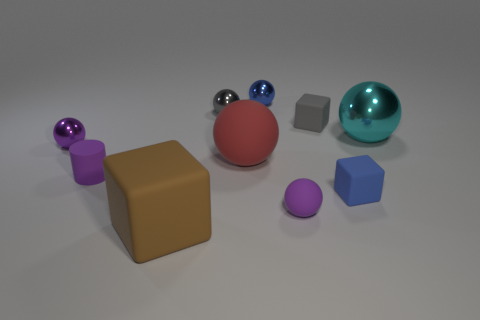What objects in the image are glossy? The objects that appear glossy in the image include the large teal sphere on the right, as well as the smaller blue and purple spheres. Their reflective surfaces produce highlights and mirrored images of the environment, indicating their glossy texture. 